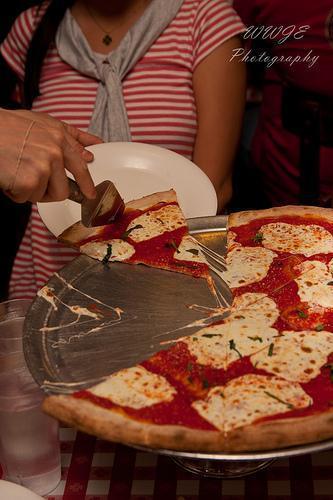How many slices of pizza are there?
Give a very brief answer. 5. How many people are in this photo?
Give a very brief answer. 2. 